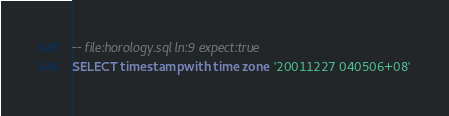Convert code to text. <code><loc_0><loc_0><loc_500><loc_500><_SQL_>-- file:horology.sql ln:9 expect:true
SELECT timestamp with time zone '20011227 040506+08'
</code> 